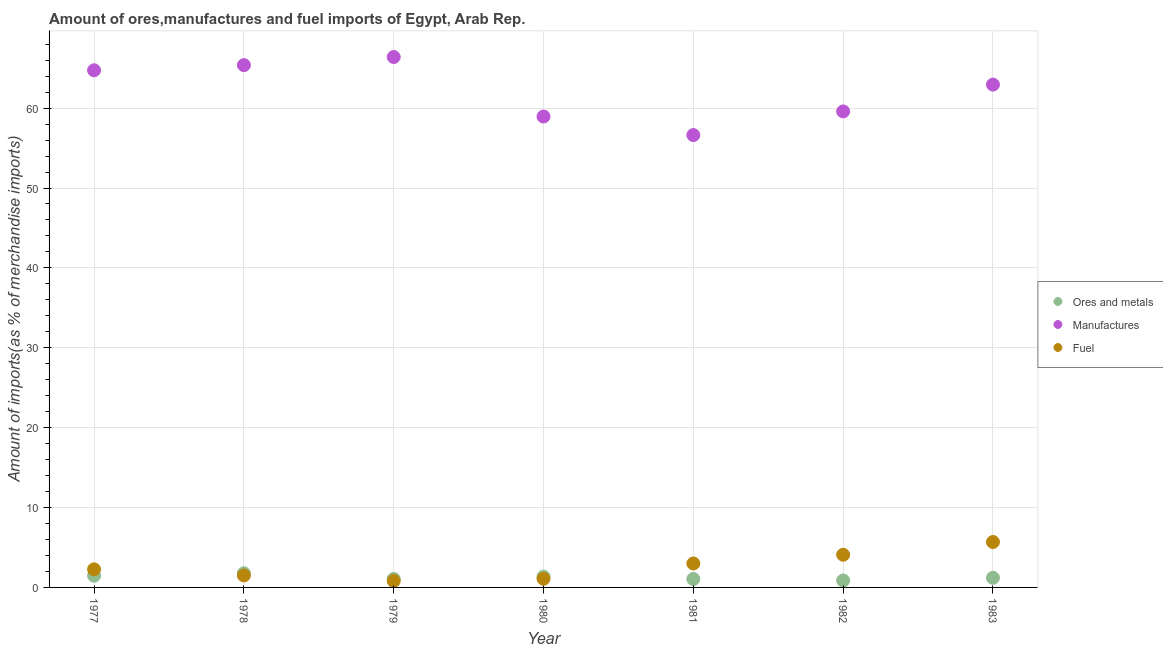How many different coloured dotlines are there?
Keep it short and to the point. 3. Is the number of dotlines equal to the number of legend labels?
Offer a very short reply. Yes. What is the percentage of manufactures imports in 1981?
Provide a short and direct response. 56.63. Across all years, what is the maximum percentage of ores and metals imports?
Your answer should be compact. 1.77. Across all years, what is the minimum percentage of ores and metals imports?
Provide a succinct answer. 0.87. In which year was the percentage of manufactures imports maximum?
Offer a very short reply. 1979. What is the total percentage of fuel imports in the graph?
Ensure brevity in your answer.  18.44. What is the difference between the percentage of fuel imports in 1981 and that in 1982?
Keep it short and to the point. -1.09. What is the difference between the percentage of fuel imports in 1982 and the percentage of ores and metals imports in 1977?
Your response must be concise. 2.63. What is the average percentage of fuel imports per year?
Provide a succinct answer. 2.63. In the year 1983, what is the difference between the percentage of ores and metals imports and percentage of fuel imports?
Provide a succinct answer. -4.48. In how many years, is the percentage of manufactures imports greater than 56 %?
Your response must be concise. 7. What is the ratio of the percentage of manufactures imports in 1978 to that in 1980?
Your answer should be very brief. 1.11. Is the difference between the percentage of ores and metals imports in 1981 and 1982 greater than the difference between the percentage of fuel imports in 1981 and 1982?
Give a very brief answer. Yes. What is the difference between the highest and the second highest percentage of manufactures imports?
Your answer should be very brief. 1.01. What is the difference between the highest and the lowest percentage of manufactures imports?
Make the answer very short. 9.77. Is the percentage of manufactures imports strictly less than the percentage of ores and metals imports over the years?
Make the answer very short. No. How many years are there in the graph?
Provide a succinct answer. 7. Does the graph contain any zero values?
Provide a succinct answer. No. Does the graph contain grids?
Ensure brevity in your answer.  Yes. What is the title of the graph?
Your answer should be very brief. Amount of ores,manufactures and fuel imports of Egypt, Arab Rep. Does "Liquid fuel" appear as one of the legend labels in the graph?
Offer a very short reply. No. What is the label or title of the Y-axis?
Offer a very short reply. Amount of imports(as % of merchandise imports). What is the Amount of imports(as % of merchandise imports) of Ores and metals in 1977?
Your response must be concise. 1.47. What is the Amount of imports(as % of merchandise imports) of Manufactures in 1977?
Your answer should be very brief. 64.74. What is the Amount of imports(as % of merchandise imports) in Fuel in 1977?
Provide a short and direct response. 2.27. What is the Amount of imports(as % of merchandise imports) in Ores and metals in 1978?
Make the answer very short. 1.77. What is the Amount of imports(as % of merchandise imports) in Manufactures in 1978?
Your answer should be very brief. 65.38. What is the Amount of imports(as % of merchandise imports) in Fuel in 1978?
Make the answer very short. 1.5. What is the Amount of imports(as % of merchandise imports) of Ores and metals in 1979?
Offer a terse response. 1.06. What is the Amount of imports(as % of merchandise imports) in Manufactures in 1979?
Keep it short and to the point. 66.4. What is the Amount of imports(as % of merchandise imports) in Fuel in 1979?
Your response must be concise. 0.81. What is the Amount of imports(as % of merchandise imports) in Ores and metals in 1980?
Your answer should be very brief. 1.34. What is the Amount of imports(as % of merchandise imports) of Manufactures in 1980?
Make the answer very short. 58.95. What is the Amount of imports(as % of merchandise imports) of Fuel in 1980?
Your response must be concise. 1.09. What is the Amount of imports(as % of merchandise imports) of Ores and metals in 1981?
Offer a very short reply. 1.05. What is the Amount of imports(as % of merchandise imports) of Manufactures in 1981?
Provide a short and direct response. 56.63. What is the Amount of imports(as % of merchandise imports) in Fuel in 1981?
Provide a short and direct response. 3. What is the Amount of imports(as % of merchandise imports) in Ores and metals in 1982?
Your response must be concise. 0.87. What is the Amount of imports(as % of merchandise imports) of Manufactures in 1982?
Provide a short and direct response. 59.58. What is the Amount of imports(as % of merchandise imports) in Fuel in 1982?
Make the answer very short. 4.09. What is the Amount of imports(as % of merchandise imports) in Ores and metals in 1983?
Offer a terse response. 1.2. What is the Amount of imports(as % of merchandise imports) of Manufactures in 1983?
Your response must be concise. 62.94. What is the Amount of imports(as % of merchandise imports) in Fuel in 1983?
Provide a short and direct response. 5.68. Across all years, what is the maximum Amount of imports(as % of merchandise imports) in Ores and metals?
Offer a very short reply. 1.77. Across all years, what is the maximum Amount of imports(as % of merchandise imports) of Manufactures?
Provide a succinct answer. 66.4. Across all years, what is the maximum Amount of imports(as % of merchandise imports) in Fuel?
Provide a succinct answer. 5.68. Across all years, what is the minimum Amount of imports(as % of merchandise imports) in Ores and metals?
Provide a short and direct response. 0.87. Across all years, what is the minimum Amount of imports(as % of merchandise imports) in Manufactures?
Your answer should be very brief. 56.63. Across all years, what is the minimum Amount of imports(as % of merchandise imports) of Fuel?
Your answer should be compact. 0.81. What is the total Amount of imports(as % of merchandise imports) in Ores and metals in the graph?
Give a very brief answer. 8.76. What is the total Amount of imports(as % of merchandise imports) of Manufactures in the graph?
Ensure brevity in your answer.  434.62. What is the total Amount of imports(as % of merchandise imports) in Fuel in the graph?
Ensure brevity in your answer.  18.44. What is the difference between the Amount of imports(as % of merchandise imports) of Ores and metals in 1977 and that in 1978?
Ensure brevity in your answer.  -0.31. What is the difference between the Amount of imports(as % of merchandise imports) of Manufactures in 1977 and that in 1978?
Your response must be concise. -0.65. What is the difference between the Amount of imports(as % of merchandise imports) in Fuel in 1977 and that in 1978?
Make the answer very short. 0.77. What is the difference between the Amount of imports(as % of merchandise imports) of Ores and metals in 1977 and that in 1979?
Give a very brief answer. 0.41. What is the difference between the Amount of imports(as % of merchandise imports) in Manufactures in 1977 and that in 1979?
Your answer should be very brief. -1.66. What is the difference between the Amount of imports(as % of merchandise imports) of Fuel in 1977 and that in 1979?
Give a very brief answer. 1.46. What is the difference between the Amount of imports(as % of merchandise imports) of Ores and metals in 1977 and that in 1980?
Provide a short and direct response. 0.12. What is the difference between the Amount of imports(as % of merchandise imports) of Manufactures in 1977 and that in 1980?
Provide a short and direct response. 5.79. What is the difference between the Amount of imports(as % of merchandise imports) of Fuel in 1977 and that in 1980?
Give a very brief answer. 1.18. What is the difference between the Amount of imports(as % of merchandise imports) of Ores and metals in 1977 and that in 1981?
Provide a succinct answer. 0.41. What is the difference between the Amount of imports(as % of merchandise imports) of Manufactures in 1977 and that in 1981?
Your answer should be very brief. 8.11. What is the difference between the Amount of imports(as % of merchandise imports) in Fuel in 1977 and that in 1981?
Provide a succinct answer. -0.73. What is the difference between the Amount of imports(as % of merchandise imports) of Ores and metals in 1977 and that in 1982?
Make the answer very short. 0.6. What is the difference between the Amount of imports(as % of merchandise imports) in Manufactures in 1977 and that in 1982?
Ensure brevity in your answer.  5.15. What is the difference between the Amount of imports(as % of merchandise imports) in Fuel in 1977 and that in 1982?
Your answer should be very brief. -1.83. What is the difference between the Amount of imports(as % of merchandise imports) in Ores and metals in 1977 and that in 1983?
Ensure brevity in your answer.  0.26. What is the difference between the Amount of imports(as % of merchandise imports) in Manufactures in 1977 and that in 1983?
Your answer should be very brief. 1.79. What is the difference between the Amount of imports(as % of merchandise imports) in Fuel in 1977 and that in 1983?
Offer a very short reply. -3.42. What is the difference between the Amount of imports(as % of merchandise imports) in Ores and metals in 1978 and that in 1979?
Your answer should be very brief. 0.72. What is the difference between the Amount of imports(as % of merchandise imports) in Manufactures in 1978 and that in 1979?
Provide a succinct answer. -1.01. What is the difference between the Amount of imports(as % of merchandise imports) in Fuel in 1978 and that in 1979?
Keep it short and to the point. 0.69. What is the difference between the Amount of imports(as % of merchandise imports) of Ores and metals in 1978 and that in 1980?
Ensure brevity in your answer.  0.43. What is the difference between the Amount of imports(as % of merchandise imports) in Manufactures in 1978 and that in 1980?
Your response must be concise. 6.43. What is the difference between the Amount of imports(as % of merchandise imports) in Fuel in 1978 and that in 1980?
Ensure brevity in your answer.  0.41. What is the difference between the Amount of imports(as % of merchandise imports) in Ores and metals in 1978 and that in 1981?
Provide a succinct answer. 0.72. What is the difference between the Amount of imports(as % of merchandise imports) in Manufactures in 1978 and that in 1981?
Your answer should be compact. 8.76. What is the difference between the Amount of imports(as % of merchandise imports) in Fuel in 1978 and that in 1981?
Provide a short and direct response. -1.5. What is the difference between the Amount of imports(as % of merchandise imports) in Ores and metals in 1978 and that in 1982?
Your answer should be compact. 0.91. What is the difference between the Amount of imports(as % of merchandise imports) of Manufactures in 1978 and that in 1982?
Provide a succinct answer. 5.8. What is the difference between the Amount of imports(as % of merchandise imports) of Fuel in 1978 and that in 1982?
Provide a short and direct response. -2.59. What is the difference between the Amount of imports(as % of merchandise imports) in Ores and metals in 1978 and that in 1983?
Keep it short and to the point. 0.57. What is the difference between the Amount of imports(as % of merchandise imports) of Manufactures in 1978 and that in 1983?
Your answer should be compact. 2.44. What is the difference between the Amount of imports(as % of merchandise imports) in Fuel in 1978 and that in 1983?
Provide a short and direct response. -4.19. What is the difference between the Amount of imports(as % of merchandise imports) in Ores and metals in 1979 and that in 1980?
Give a very brief answer. -0.28. What is the difference between the Amount of imports(as % of merchandise imports) of Manufactures in 1979 and that in 1980?
Your answer should be very brief. 7.45. What is the difference between the Amount of imports(as % of merchandise imports) in Fuel in 1979 and that in 1980?
Keep it short and to the point. -0.28. What is the difference between the Amount of imports(as % of merchandise imports) of Ores and metals in 1979 and that in 1981?
Your answer should be compact. 0. What is the difference between the Amount of imports(as % of merchandise imports) of Manufactures in 1979 and that in 1981?
Your answer should be compact. 9.77. What is the difference between the Amount of imports(as % of merchandise imports) in Fuel in 1979 and that in 1981?
Keep it short and to the point. -2.19. What is the difference between the Amount of imports(as % of merchandise imports) of Ores and metals in 1979 and that in 1982?
Your answer should be very brief. 0.19. What is the difference between the Amount of imports(as % of merchandise imports) in Manufactures in 1979 and that in 1982?
Offer a very short reply. 6.81. What is the difference between the Amount of imports(as % of merchandise imports) in Fuel in 1979 and that in 1982?
Your answer should be very brief. -3.28. What is the difference between the Amount of imports(as % of merchandise imports) in Ores and metals in 1979 and that in 1983?
Give a very brief answer. -0.15. What is the difference between the Amount of imports(as % of merchandise imports) of Manufactures in 1979 and that in 1983?
Keep it short and to the point. 3.45. What is the difference between the Amount of imports(as % of merchandise imports) of Fuel in 1979 and that in 1983?
Provide a succinct answer. -4.87. What is the difference between the Amount of imports(as % of merchandise imports) in Ores and metals in 1980 and that in 1981?
Offer a terse response. 0.29. What is the difference between the Amount of imports(as % of merchandise imports) of Manufactures in 1980 and that in 1981?
Give a very brief answer. 2.32. What is the difference between the Amount of imports(as % of merchandise imports) in Fuel in 1980 and that in 1981?
Your answer should be very brief. -1.91. What is the difference between the Amount of imports(as % of merchandise imports) in Ores and metals in 1980 and that in 1982?
Give a very brief answer. 0.47. What is the difference between the Amount of imports(as % of merchandise imports) of Manufactures in 1980 and that in 1982?
Provide a succinct answer. -0.63. What is the difference between the Amount of imports(as % of merchandise imports) of Fuel in 1980 and that in 1982?
Your response must be concise. -3.01. What is the difference between the Amount of imports(as % of merchandise imports) of Ores and metals in 1980 and that in 1983?
Give a very brief answer. 0.14. What is the difference between the Amount of imports(as % of merchandise imports) of Manufactures in 1980 and that in 1983?
Provide a succinct answer. -3.99. What is the difference between the Amount of imports(as % of merchandise imports) of Fuel in 1980 and that in 1983?
Offer a terse response. -4.6. What is the difference between the Amount of imports(as % of merchandise imports) of Ores and metals in 1981 and that in 1982?
Your response must be concise. 0.19. What is the difference between the Amount of imports(as % of merchandise imports) of Manufactures in 1981 and that in 1982?
Ensure brevity in your answer.  -2.96. What is the difference between the Amount of imports(as % of merchandise imports) in Fuel in 1981 and that in 1982?
Make the answer very short. -1.09. What is the difference between the Amount of imports(as % of merchandise imports) of Ores and metals in 1981 and that in 1983?
Provide a short and direct response. -0.15. What is the difference between the Amount of imports(as % of merchandise imports) in Manufactures in 1981 and that in 1983?
Provide a short and direct response. -6.32. What is the difference between the Amount of imports(as % of merchandise imports) of Fuel in 1981 and that in 1983?
Offer a terse response. -2.69. What is the difference between the Amount of imports(as % of merchandise imports) in Ores and metals in 1982 and that in 1983?
Keep it short and to the point. -0.34. What is the difference between the Amount of imports(as % of merchandise imports) in Manufactures in 1982 and that in 1983?
Ensure brevity in your answer.  -3.36. What is the difference between the Amount of imports(as % of merchandise imports) in Fuel in 1982 and that in 1983?
Give a very brief answer. -1.59. What is the difference between the Amount of imports(as % of merchandise imports) in Ores and metals in 1977 and the Amount of imports(as % of merchandise imports) in Manufactures in 1978?
Your answer should be very brief. -63.92. What is the difference between the Amount of imports(as % of merchandise imports) of Ores and metals in 1977 and the Amount of imports(as % of merchandise imports) of Fuel in 1978?
Give a very brief answer. -0.03. What is the difference between the Amount of imports(as % of merchandise imports) in Manufactures in 1977 and the Amount of imports(as % of merchandise imports) in Fuel in 1978?
Make the answer very short. 63.24. What is the difference between the Amount of imports(as % of merchandise imports) in Ores and metals in 1977 and the Amount of imports(as % of merchandise imports) in Manufactures in 1979?
Keep it short and to the point. -64.93. What is the difference between the Amount of imports(as % of merchandise imports) in Ores and metals in 1977 and the Amount of imports(as % of merchandise imports) in Fuel in 1979?
Your answer should be very brief. 0.66. What is the difference between the Amount of imports(as % of merchandise imports) of Manufactures in 1977 and the Amount of imports(as % of merchandise imports) of Fuel in 1979?
Offer a very short reply. 63.93. What is the difference between the Amount of imports(as % of merchandise imports) in Ores and metals in 1977 and the Amount of imports(as % of merchandise imports) in Manufactures in 1980?
Ensure brevity in your answer.  -57.48. What is the difference between the Amount of imports(as % of merchandise imports) of Ores and metals in 1977 and the Amount of imports(as % of merchandise imports) of Fuel in 1980?
Make the answer very short. 0.38. What is the difference between the Amount of imports(as % of merchandise imports) in Manufactures in 1977 and the Amount of imports(as % of merchandise imports) in Fuel in 1980?
Ensure brevity in your answer.  63.65. What is the difference between the Amount of imports(as % of merchandise imports) of Ores and metals in 1977 and the Amount of imports(as % of merchandise imports) of Manufactures in 1981?
Your answer should be compact. -55.16. What is the difference between the Amount of imports(as % of merchandise imports) in Ores and metals in 1977 and the Amount of imports(as % of merchandise imports) in Fuel in 1981?
Ensure brevity in your answer.  -1.53. What is the difference between the Amount of imports(as % of merchandise imports) of Manufactures in 1977 and the Amount of imports(as % of merchandise imports) of Fuel in 1981?
Offer a very short reply. 61.74. What is the difference between the Amount of imports(as % of merchandise imports) in Ores and metals in 1977 and the Amount of imports(as % of merchandise imports) in Manufactures in 1982?
Make the answer very short. -58.12. What is the difference between the Amount of imports(as % of merchandise imports) in Ores and metals in 1977 and the Amount of imports(as % of merchandise imports) in Fuel in 1982?
Offer a terse response. -2.63. What is the difference between the Amount of imports(as % of merchandise imports) in Manufactures in 1977 and the Amount of imports(as % of merchandise imports) in Fuel in 1982?
Provide a short and direct response. 60.64. What is the difference between the Amount of imports(as % of merchandise imports) in Ores and metals in 1977 and the Amount of imports(as % of merchandise imports) in Manufactures in 1983?
Your answer should be very brief. -61.48. What is the difference between the Amount of imports(as % of merchandise imports) in Ores and metals in 1977 and the Amount of imports(as % of merchandise imports) in Fuel in 1983?
Ensure brevity in your answer.  -4.22. What is the difference between the Amount of imports(as % of merchandise imports) of Manufactures in 1977 and the Amount of imports(as % of merchandise imports) of Fuel in 1983?
Keep it short and to the point. 59.05. What is the difference between the Amount of imports(as % of merchandise imports) in Ores and metals in 1978 and the Amount of imports(as % of merchandise imports) in Manufactures in 1979?
Your response must be concise. -64.62. What is the difference between the Amount of imports(as % of merchandise imports) of Ores and metals in 1978 and the Amount of imports(as % of merchandise imports) of Fuel in 1979?
Provide a short and direct response. 0.96. What is the difference between the Amount of imports(as % of merchandise imports) of Manufactures in 1978 and the Amount of imports(as % of merchandise imports) of Fuel in 1979?
Give a very brief answer. 64.57. What is the difference between the Amount of imports(as % of merchandise imports) in Ores and metals in 1978 and the Amount of imports(as % of merchandise imports) in Manufactures in 1980?
Give a very brief answer. -57.18. What is the difference between the Amount of imports(as % of merchandise imports) in Ores and metals in 1978 and the Amount of imports(as % of merchandise imports) in Fuel in 1980?
Offer a very short reply. 0.69. What is the difference between the Amount of imports(as % of merchandise imports) in Manufactures in 1978 and the Amount of imports(as % of merchandise imports) in Fuel in 1980?
Make the answer very short. 64.3. What is the difference between the Amount of imports(as % of merchandise imports) of Ores and metals in 1978 and the Amount of imports(as % of merchandise imports) of Manufactures in 1981?
Your answer should be compact. -54.85. What is the difference between the Amount of imports(as % of merchandise imports) in Ores and metals in 1978 and the Amount of imports(as % of merchandise imports) in Fuel in 1981?
Your response must be concise. -1.22. What is the difference between the Amount of imports(as % of merchandise imports) in Manufactures in 1978 and the Amount of imports(as % of merchandise imports) in Fuel in 1981?
Your response must be concise. 62.39. What is the difference between the Amount of imports(as % of merchandise imports) in Ores and metals in 1978 and the Amount of imports(as % of merchandise imports) in Manufactures in 1982?
Your response must be concise. -57.81. What is the difference between the Amount of imports(as % of merchandise imports) of Ores and metals in 1978 and the Amount of imports(as % of merchandise imports) of Fuel in 1982?
Make the answer very short. -2.32. What is the difference between the Amount of imports(as % of merchandise imports) of Manufactures in 1978 and the Amount of imports(as % of merchandise imports) of Fuel in 1982?
Offer a terse response. 61.29. What is the difference between the Amount of imports(as % of merchandise imports) in Ores and metals in 1978 and the Amount of imports(as % of merchandise imports) in Manufactures in 1983?
Ensure brevity in your answer.  -61.17. What is the difference between the Amount of imports(as % of merchandise imports) of Ores and metals in 1978 and the Amount of imports(as % of merchandise imports) of Fuel in 1983?
Make the answer very short. -3.91. What is the difference between the Amount of imports(as % of merchandise imports) of Manufactures in 1978 and the Amount of imports(as % of merchandise imports) of Fuel in 1983?
Offer a very short reply. 59.7. What is the difference between the Amount of imports(as % of merchandise imports) of Ores and metals in 1979 and the Amount of imports(as % of merchandise imports) of Manufactures in 1980?
Your answer should be compact. -57.89. What is the difference between the Amount of imports(as % of merchandise imports) in Ores and metals in 1979 and the Amount of imports(as % of merchandise imports) in Fuel in 1980?
Your response must be concise. -0.03. What is the difference between the Amount of imports(as % of merchandise imports) in Manufactures in 1979 and the Amount of imports(as % of merchandise imports) in Fuel in 1980?
Your response must be concise. 65.31. What is the difference between the Amount of imports(as % of merchandise imports) of Ores and metals in 1979 and the Amount of imports(as % of merchandise imports) of Manufactures in 1981?
Make the answer very short. -55.57. What is the difference between the Amount of imports(as % of merchandise imports) of Ores and metals in 1979 and the Amount of imports(as % of merchandise imports) of Fuel in 1981?
Give a very brief answer. -1.94. What is the difference between the Amount of imports(as % of merchandise imports) of Manufactures in 1979 and the Amount of imports(as % of merchandise imports) of Fuel in 1981?
Offer a terse response. 63.4. What is the difference between the Amount of imports(as % of merchandise imports) of Ores and metals in 1979 and the Amount of imports(as % of merchandise imports) of Manufactures in 1982?
Ensure brevity in your answer.  -58.53. What is the difference between the Amount of imports(as % of merchandise imports) of Ores and metals in 1979 and the Amount of imports(as % of merchandise imports) of Fuel in 1982?
Provide a short and direct response. -3.04. What is the difference between the Amount of imports(as % of merchandise imports) of Manufactures in 1979 and the Amount of imports(as % of merchandise imports) of Fuel in 1982?
Your response must be concise. 62.3. What is the difference between the Amount of imports(as % of merchandise imports) of Ores and metals in 1979 and the Amount of imports(as % of merchandise imports) of Manufactures in 1983?
Make the answer very short. -61.89. What is the difference between the Amount of imports(as % of merchandise imports) of Ores and metals in 1979 and the Amount of imports(as % of merchandise imports) of Fuel in 1983?
Your response must be concise. -4.63. What is the difference between the Amount of imports(as % of merchandise imports) in Manufactures in 1979 and the Amount of imports(as % of merchandise imports) in Fuel in 1983?
Offer a very short reply. 60.71. What is the difference between the Amount of imports(as % of merchandise imports) in Ores and metals in 1980 and the Amount of imports(as % of merchandise imports) in Manufactures in 1981?
Provide a succinct answer. -55.28. What is the difference between the Amount of imports(as % of merchandise imports) in Ores and metals in 1980 and the Amount of imports(as % of merchandise imports) in Fuel in 1981?
Keep it short and to the point. -1.66. What is the difference between the Amount of imports(as % of merchandise imports) in Manufactures in 1980 and the Amount of imports(as % of merchandise imports) in Fuel in 1981?
Give a very brief answer. 55.95. What is the difference between the Amount of imports(as % of merchandise imports) in Ores and metals in 1980 and the Amount of imports(as % of merchandise imports) in Manufactures in 1982?
Provide a short and direct response. -58.24. What is the difference between the Amount of imports(as % of merchandise imports) of Ores and metals in 1980 and the Amount of imports(as % of merchandise imports) of Fuel in 1982?
Make the answer very short. -2.75. What is the difference between the Amount of imports(as % of merchandise imports) in Manufactures in 1980 and the Amount of imports(as % of merchandise imports) in Fuel in 1982?
Ensure brevity in your answer.  54.86. What is the difference between the Amount of imports(as % of merchandise imports) in Ores and metals in 1980 and the Amount of imports(as % of merchandise imports) in Manufactures in 1983?
Make the answer very short. -61.6. What is the difference between the Amount of imports(as % of merchandise imports) of Ores and metals in 1980 and the Amount of imports(as % of merchandise imports) of Fuel in 1983?
Provide a succinct answer. -4.34. What is the difference between the Amount of imports(as % of merchandise imports) in Manufactures in 1980 and the Amount of imports(as % of merchandise imports) in Fuel in 1983?
Your answer should be compact. 53.27. What is the difference between the Amount of imports(as % of merchandise imports) in Ores and metals in 1981 and the Amount of imports(as % of merchandise imports) in Manufactures in 1982?
Keep it short and to the point. -58.53. What is the difference between the Amount of imports(as % of merchandise imports) in Ores and metals in 1981 and the Amount of imports(as % of merchandise imports) in Fuel in 1982?
Ensure brevity in your answer.  -3.04. What is the difference between the Amount of imports(as % of merchandise imports) in Manufactures in 1981 and the Amount of imports(as % of merchandise imports) in Fuel in 1982?
Your answer should be compact. 52.53. What is the difference between the Amount of imports(as % of merchandise imports) in Ores and metals in 1981 and the Amount of imports(as % of merchandise imports) in Manufactures in 1983?
Your answer should be very brief. -61.89. What is the difference between the Amount of imports(as % of merchandise imports) in Ores and metals in 1981 and the Amount of imports(as % of merchandise imports) in Fuel in 1983?
Provide a succinct answer. -4.63. What is the difference between the Amount of imports(as % of merchandise imports) of Manufactures in 1981 and the Amount of imports(as % of merchandise imports) of Fuel in 1983?
Give a very brief answer. 50.94. What is the difference between the Amount of imports(as % of merchandise imports) of Ores and metals in 1982 and the Amount of imports(as % of merchandise imports) of Manufactures in 1983?
Your answer should be compact. -62.08. What is the difference between the Amount of imports(as % of merchandise imports) in Ores and metals in 1982 and the Amount of imports(as % of merchandise imports) in Fuel in 1983?
Offer a terse response. -4.82. What is the difference between the Amount of imports(as % of merchandise imports) in Manufactures in 1982 and the Amount of imports(as % of merchandise imports) in Fuel in 1983?
Keep it short and to the point. 53.9. What is the average Amount of imports(as % of merchandise imports) in Ores and metals per year?
Your response must be concise. 1.25. What is the average Amount of imports(as % of merchandise imports) of Manufactures per year?
Your response must be concise. 62.09. What is the average Amount of imports(as % of merchandise imports) in Fuel per year?
Ensure brevity in your answer.  2.63. In the year 1977, what is the difference between the Amount of imports(as % of merchandise imports) in Ores and metals and Amount of imports(as % of merchandise imports) in Manufactures?
Provide a short and direct response. -63.27. In the year 1977, what is the difference between the Amount of imports(as % of merchandise imports) in Ores and metals and Amount of imports(as % of merchandise imports) in Fuel?
Keep it short and to the point. -0.8. In the year 1977, what is the difference between the Amount of imports(as % of merchandise imports) of Manufactures and Amount of imports(as % of merchandise imports) of Fuel?
Provide a succinct answer. 62.47. In the year 1978, what is the difference between the Amount of imports(as % of merchandise imports) in Ores and metals and Amount of imports(as % of merchandise imports) in Manufactures?
Keep it short and to the point. -63.61. In the year 1978, what is the difference between the Amount of imports(as % of merchandise imports) of Ores and metals and Amount of imports(as % of merchandise imports) of Fuel?
Give a very brief answer. 0.28. In the year 1978, what is the difference between the Amount of imports(as % of merchandise imports) of Manufactures and Amount of imports(as % of merchandise imports) of Fuel?
Provide a succinct answer. 63.88. In the year 1979, what is the difference between the Amount of imports(as % of merchandise imports) of Ores and metals and Amount of imports(as % of merchandise imports) of Manufactures?
Keep it short and to the point. -65.34. In the year 1979, what is the difference between the Amount of imports(as % of merchandise imports) of Ores and metals and Amount of imports(as % of merchandise imports) of Fuel?
Keep it short and to the point. 0.25. In the year 1979, what is the difference between the Amount of imports(as % of merchandise imports) in Manufactures and Amount of imports(as % of merchandise imports) in Fuel?
Ensure brevity in your answer.  65.59. In the year 1980, what is the difference between the Amount of imports(as % of merchandise imports) in Ores and metals and Amount of imports(as % of merchandise imports) in Manufactures?
Give a very brief answer. -57.61. In the year 1980, what is the difference between the Amount of imports(as % of merchandise imports) of Ores and metals and Amount of imports(as % of merchandise imports) of Fuel?
Your answer should be compact. 0.26. In the year 1980, what is the difference between the Amount of imports(as % of merchandise imports) in Manufactures and Amount of imports(as % of merchandise imports) in Fuel?
Your answer should be compact. 57.86. In the year 1981, what is the difference between the Amount of imports(as % of merchandise imports) in Ores and metals and Amount of imports(as % of merchandise imports) in Manufactures?
Provide a succinct answer. -55.57. In the year 1981, what is the difference between the Amount of imports(as % of merchandise imports) of Ores and metals and Amount of imports(as % of merchandise imports) of Fuel?
Provide a short and direct response. -1.94. In the year 1981, what is the difference between the Amount of imports(as % of merchandise imports) of Manufactures and Amount of imports(as % of merchandise imports) of Fuel?
Offer a terse response. 53.63. In the year 1982, what is the difference between the Amount of imports(as % of merchandise imports) of Ores and metals and Amount of imports(as % of merchandise imports) of Manufactures?
Your response must be concise. -58.72. In the year 1982, what is the difference between the Amount of imports(as % of merchandise imports) of Ores and metals and Amount of imports(as % of merchandise imports) of Fuel?
Make the answer very short. -3.22. In the year 1982, what is the difference between the Amount of imports(as % of merchandise imports) of Manufactures and Amount of imports(as % of merchandise imports) of Fuel?
Give a very brief answer. 55.49. In the year 1983, what is the difference between the Amount of imports(as % of merchandise imports) of Ores and metals and Amount of imports(as % of merchandise imports) of Manufactures?
Ensure brevity in your answer.  -61.74. In the year 1983, what is the difference between the Amount of imports(as % of merchandise imports) of Ores and metals and Amount of imports(as % of merchandise imports) of Fuel?
Provide a succinct answer. -4.48. In the year 1983, what is the difference between the Amount of imports(as % of merchandise imports) in Manufactures and Amount of imports(as % of merchandise imports) in Fuel?
Give a very brief answer. 57.26. What is the ratio of the Amount of imports(as % of merchandise imports) in Ores and metals in 1977 to that in 1978?
Keep it short and to the point. 0.83. What is the ratio of the Amount of imports(as % of merchandise imports) of Fuel in 1977 to that in 1978?
Provide a short and direct response. 1.51. What is the ratio of the Amount of imports(as % of merchandise imports) of Ores and metals in 1977 to that in 1979?
Make the answer very short. 1.39. What is the ratio of the Amount of imports(as % of merchandise imports) in Manufactures in 1977 to that in 1979?
Your answer should be very brief. 0.97. What is the ratio of the Amount of imports(as % of merchandise imports) of Fuel in 1977 to that in 1979?
Make the answer very short. 2.8. What is the ratio of the Amount of imports(as % of merchandise imports) in Ores and metals in 1977 to that in 1980?
Your answer should be very brief. 1.09. What is the ratio of the Amount of imports(as % of merchandise imports) of Manufactures in 1977 to that in 1980?
Provide a short and direct response. 1.1. What is the ratio of the Amount of imports(as % of merchandise imports) in Fuel in 1977 to that in 1980?
Make the answer very short. 2.09. What is the ratio of the Amount of imports(as % of merchandise imports) of Ores and metals in 1977 to that in 1981?
Provide a succinct answer. 1.39. What is the ratio of the Amount of imports(as % of merchandise imports) in Manufactures in 1977 to that in 1981?
Your answer should be compact. 1.14. What is the ratio of the Amount of imports(as % of merchandise imports) of Fuel in 1977 to that in 1981?
Ensure brevity in your answer.  0.76. What is the ratio of the Amount of imports(as % of merchandise imports) of Ores and metals in 1977 to that in 1982?
Your answer should be very brief. 1.69. What is the ratio of the Amount of imports(as % of merchandise imports) in Manufactures in 1977 to that in 1982?
Make the answer very short. 1.09. What is the ratio of the Amount of imports(as % of merchandise imports) in Fuel in 1977 to that in 1982?
Your answer should be compact. 0.55. What is the ratio of the Amount of imports(as % of merchandise imports) in Ores and metals in 1977 to that in 1983?
Give a very brief answer. 1.22. What is the ratio of the Amount of imports(as % of merchandise imports) of Manufactures in 1977 to that in 1983?
Your answer should be very brief. 1.03. What is the ratio of the Amount of imports(as % of merchandise imports) in Fuel in 1977 to that in 1983?
Ensure brevity in your answer.  0.4. What is the ratio of the Amount of imports(as % of merchandise imports) of Ores and metals in 1978 to that in 1979?
Provide a succinct answer. 1.68. What is the ratio of the Amount of imports(as % of merchandise imports) of Fuel in 1978 to that in 1979?
Provide a short and direct response. 1.85. What is the ratio of the Amount of imports(as % of merchandise imports) in Ores and metals in 1978 to that in 1980?
Offer a terse response. 1.32. What is the ratio of the Amount of imports(as % of merchandise imports) of Manufactures in 1978 to that in 1980?
Your response must be concise. 1.11. What is the ratio of the Amount of imports(as % of merchandise imports) in Fuel in 1978 to that in 1980?
Ensure brevity in your answer.  1.38. What is the ratio of the Amount of imports(as % of merchandise imports) in Ores and metals in 1978 to that in 1981?
Give a very brief answer. 1.68. What is the ratio of the Amount of imports(as % of merchandise imports) in Manufactures in 1978 to that in 1981?
Keep it short and to the point. 1.15. What is the ratio of the Amount of imports(as % of merchandise imports) in Fuel in 1978 to that in 1981?
Provide a succinct answer. 0.5. What is the ratio of the Amount of imports(as % of merchandise imports) in Ores and metals in 1978 to that in 1982?
Give a very brief answer. 2.05. What is the ratio of the Amount of imports(as % of merchandise imports) in Manufactures in 1978 to that in 1982?
Provide a short and direct response. 1.1. What is the ratio of the Amount of imports(as % of merchandise imports) of Fuel in 1978 to that in 1982?
Make the answer very short. 0.37. What is the ratio of the Amount of imports(as % of merchandise imports) in Ores and metals in 1978 to that in 1983?
Ensure brevity in your answer.  1.47. What is the ratio of the Amount of imports(as % of merchandise imports) of Manufactures in 1978 to that in 1983?
Provide a short and direct response. 1.04. What is the ratio of the Amount of imports(as % of merchandise imports) of Fuel in 1978 to that in 1983?
Keep it short and to the point. 0.26. What is the ratio of the Amount of imports(as % of merchandise imports) of Ores and metals in 1979 to that in 1980?
Provide a short and direct response. 0.79. What is the ratio of the Amount of imports(as % of merchandise imports) of Manufactures in 1979 to that in 1980?
Make the answer very short. 1.13. What is the ratio of the Amount of imports(as % of merchandise imports) in Fuel in 1979 to that in 1980?
Provide a succinct answer. 0.75. What is the ratio of the Amount of imports(as % of merchandise imports) in Ores and metals in 1979 to that in 1981?
Provide a succinct answer. 1. What is the ratio of the Amount of imports(as % of merchandise imports) of Manufactures in 1979 to that in 1981?
Provide a short and direct response. 1.17. What is the ratio of the Amount of imports(as % of merchandise imports) of Fuel in 1979 to that in 1981?
Your answer should be very brief. 0.27. What is the ratio of the Amount of imports(as % of merchandise imports) of Ores and metals in 1979 to that in 1982?
Provide a succinct answer. 1.22. What is the ratio of the Amount of imports(as % of merchandise imports) of Manufactures in 1979 to that in 1982?
Provide a short and direct response. 1.11. What is the ratio of the Amount of imports(as % of merchandise imports) of Fuel in 1979 to that in 1982?
Your answer should be very brief. 0.2. What is the ratio of the Amount of imports(as % of merchandise imports) in Ores and metals in 1979 to that in 1983?
Your answer should be very brief. 0.88. What is the ratio of the Amount of imports(as % of merchandise imports) of Manufactures in 1979 to that in 1983?
Ensure brevity in your answer.  1.05. What is the ratio of the Amount of imports(as % of merchandise imports) of Fuel in 1979 to that in 1983?
Ensure brevity in your answer.  0.14. What is the ratio of the Amount of imports(as % of merchandise imports) of Ores and metals in 1980 to that in 1981?
Offer a terse response. 1.27. What is the ratio of the Amount of imports(as % of merchandise imports) in Manufactures in 1980 to that in 1981?
Offer a very short reply. 1.04. What is the ratio of the Amount of imports(as % of merchandise imports) of Fuel in 1980 to that in 1981?
Your answer should be very brief. 0.36. What is the ratio of the Amount of imports(as % of merchandise imports) in Ores and metals in 1980 to that in 1982?
Your response must be concise. 1.55. What is the ratio of the Amount of imports(as % of merchandise imports) of Manufactures in 1980 to that in 1982?
Ensure brevity in your answer.  0.99. What is the ratio of the Amount of imports(as % of merchandise imports) of Fuel in 1980 to that in 1982?
Provide a short and direct response. 0.27. What is the ratio of the Amount of imports(as % of merchandise imports) in Ores and metals in 1980 to that in 1983?
Offer a terse response. 1.11. What is the ratio of the Amount of imports(as % of merchandise imports) of Manufactures in 1980 to that in 1983?
Offer a very short reply. 0.94. What is the ratio of the Amount of imports(as % of merchandise imports) of Fuel in 1980 to that in 1983?
Provide a short and direct response. 0.19. What is the ratio of the Amount of imports(as % of merchandise imports) of Ores and metals in 1981 to that in 1982?
Your answer should be compact. 1.22. What is the ratio of the Amount of imports(as % of merchandise imports) in Manufactures in 1981 to that in 1982?
Make the answer very short. 0.95. What is the ratio of the Amount of imports(as % of merchandise imports) of Fuel in 1981 to that in 1982?
Ensure brevity in your answer.  0.73. What is the ratio of the Amount of imports(as % of merchandise imports) of Ores and metals in 1981 to that in 1983?
Your answer should be very brief. 0.88. What is the ratio of the Amount of imports(as % of merchandise imports) of Manufactures in 1981 to that in 1983?
Make the answer very short. 0.9. What is the ratio of the Amount of imports(as % of merchandise imports) in Fuel in 1981 to that in 1983?
Make the answer very short. 0.53. What is the ratio of the Amount of imports(as % of merchandise imports) in Ores and metals in 1982 to that in 1983?
Give a very brief answer. 0.72. What is the ratio of the Amount of imports(as % of merchandise imports) in Manufactures in 1982 to that in 1983?
Provide a short and direct response. 0.95. What is the ratio of the Amount of imports(as % of merchandise imports) of Fuel in 1982 to that in 1983?
Your answer should be compact. 0.72. What is the difference between the highest and the second highest Amount of imports(as % of merchandise imports) in Ores and metals?
Your answer should be very brief. 0.31. What is the difference between the highest and the second highest Amount of imports(as % of merchandise imports) of Manufactures?
Provide a short and direct response. 1.01. What is the difference between the highest and the second highest Amount of imports(as % of merchandise imports) of Fuel?
Give a very brief answer. 1.59. What is the difference between the highest and the lowest Amount of imports(as % of merchandise imports) of Ores and metals?
Make the answer very short. 0.91. What is the difference between the highest and the lowest Amount of imports(as % of merchandise imports) of Manufactures?
Make the answer very short. 9.77. What is the difference between the highest and the lowest Amount of imports(as % of merchandise imports) of Fuel?
Ensure brevity in your answer.  4.87. 